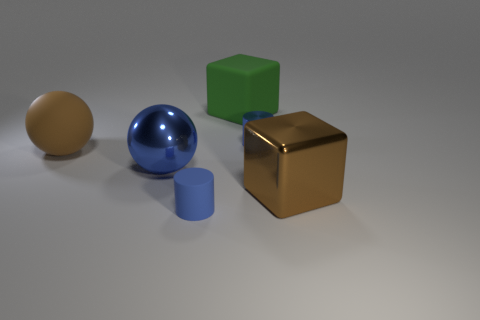What is the shape of the blue metallic thing that is the same size as the rubber cylinder?
Offer a terse response. Cylinder. How many matte things are large green cubes or big brown things?
Make the answer very short. 2. Are the blue thing that is to the right of the small blue matte thing and the big blue object that is in front of the small blue metallic thing made of the same material?
Keep it short and to the point. Yes. There is a big object that is the same material as the brown sphere; what is its color?
Ensure brevity in your answer.  Green. Are there more small cylinders in front of the big metallic block than big brown matte things that are right of the large green block?
Offer a very short reply. Yes. Are any gray objects visible?
Offer a very short reply. No. There is a object that is the same color as the large shiny block; what material is it?
Offer a very short reply. Rubber. What number of objects are either brown blocks or metal things?
Make the answer very short. 3. Is there a small metallic thing that has the same color as the metallic sphere?
Give a very brief answer. Yes. There is a tiny blue cylinder in front of the big blue ball; what number of blue rubber cylinders are in front of it?
Offer a very short reply. 0. 